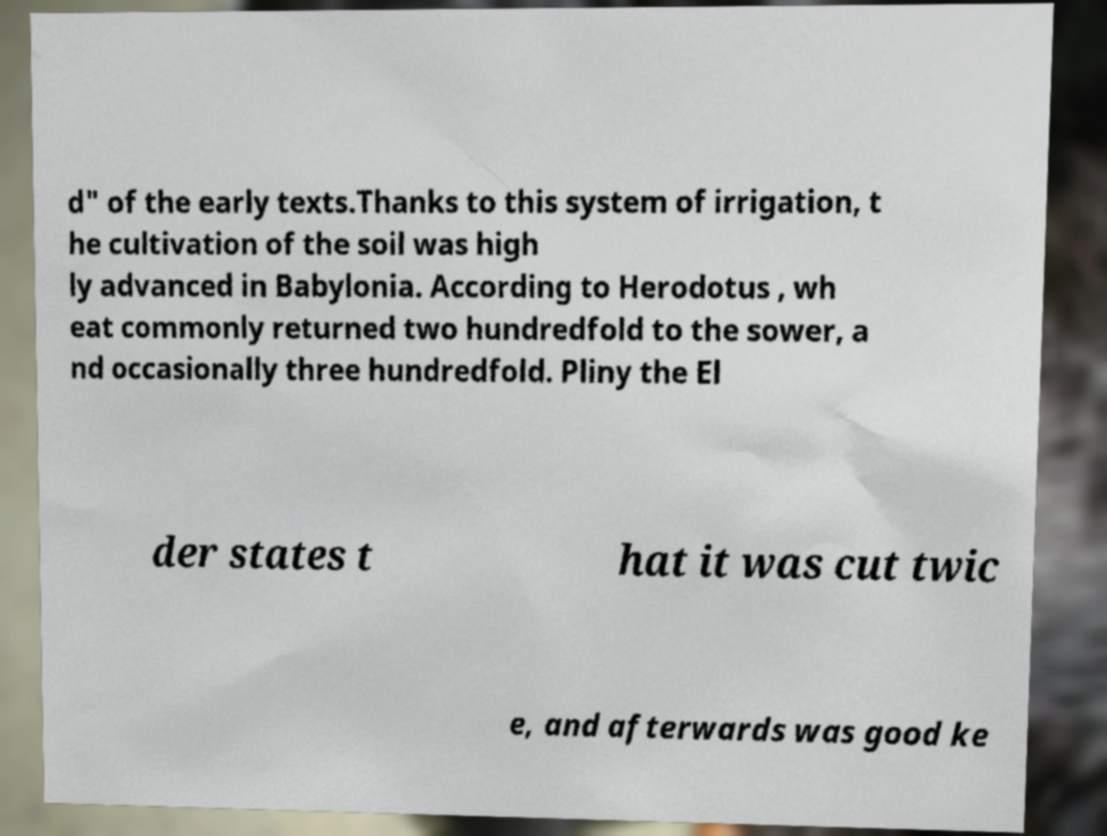Please identify and transcribe the text found in this image. d" of the early texts.Thanks to this system of irrigation, t he cultivation of the soil was high ly advanced in Babylonia. According to Herodotus , wh eat commonly returned two hundredfold to the sower, a nd occasionally three hundredfold. Pliny the El der states t hat it was cut twic e, and afterwards was good ke 